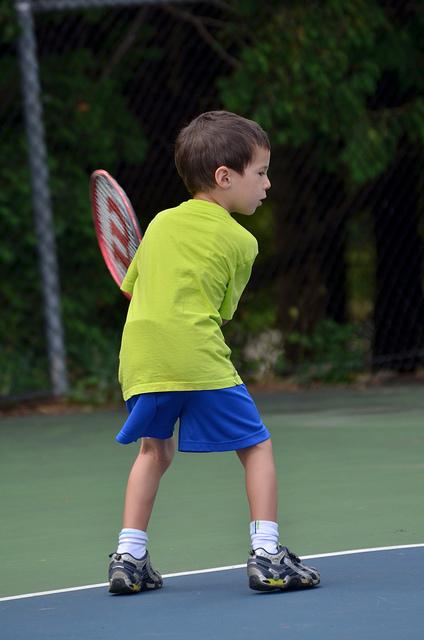Is he left handed?
Give a very brief answer. No. What color are the man's sneakers?
Quick response, please. Blue. What color is the top of the player?
Short answer required. Green. Is this Serena?
Write a very short answer. No. Where was this picture taken?
Concise answer only. Tennis court. Is this person likely to be actually playing tennis?
Concise answer only. Yes. Is it a sunny day?
Quick response, please. Yes. What is the color of the pitch?
Keep it brief. White. What is the kid doing?
Answer briefly. Playing tennis. Can the player's shadow be seen?
Give a very brief answer. No. Is tennis a healthy way to get into shape?
Short answer required. Yes. Is this photo similar to any of your own kid's photos?
Give a very brief answer. No. What color is the kid's shirt?
Write a very short answer. Yellow. 